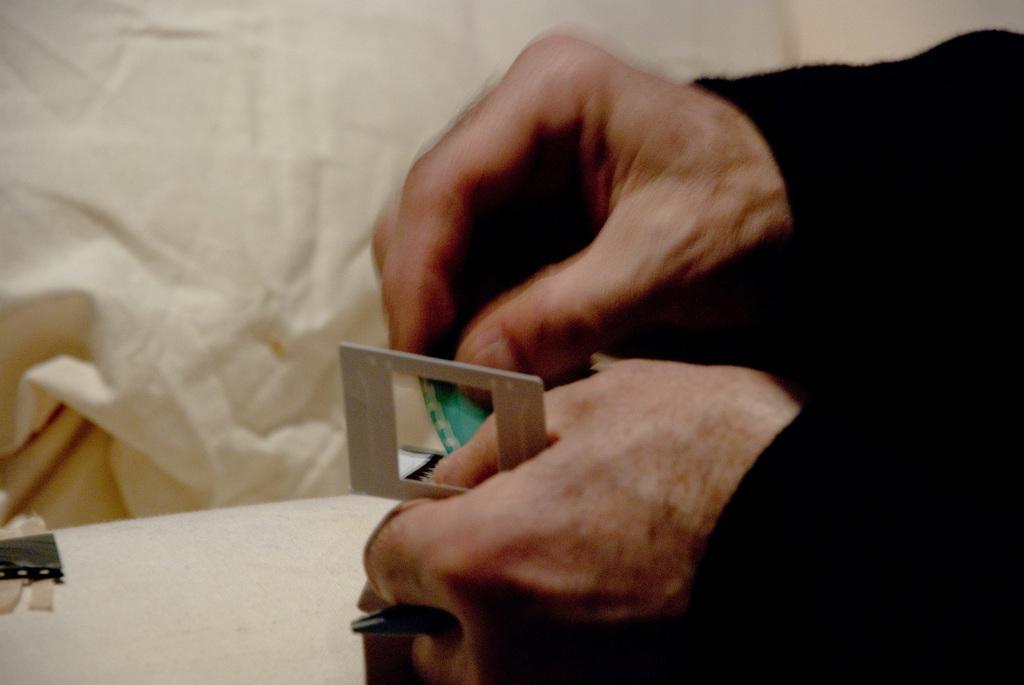How would you summarize this image in a sentence or two? In this image on the right side, I can see the hands a person. In the background, I can see a white cloth. 